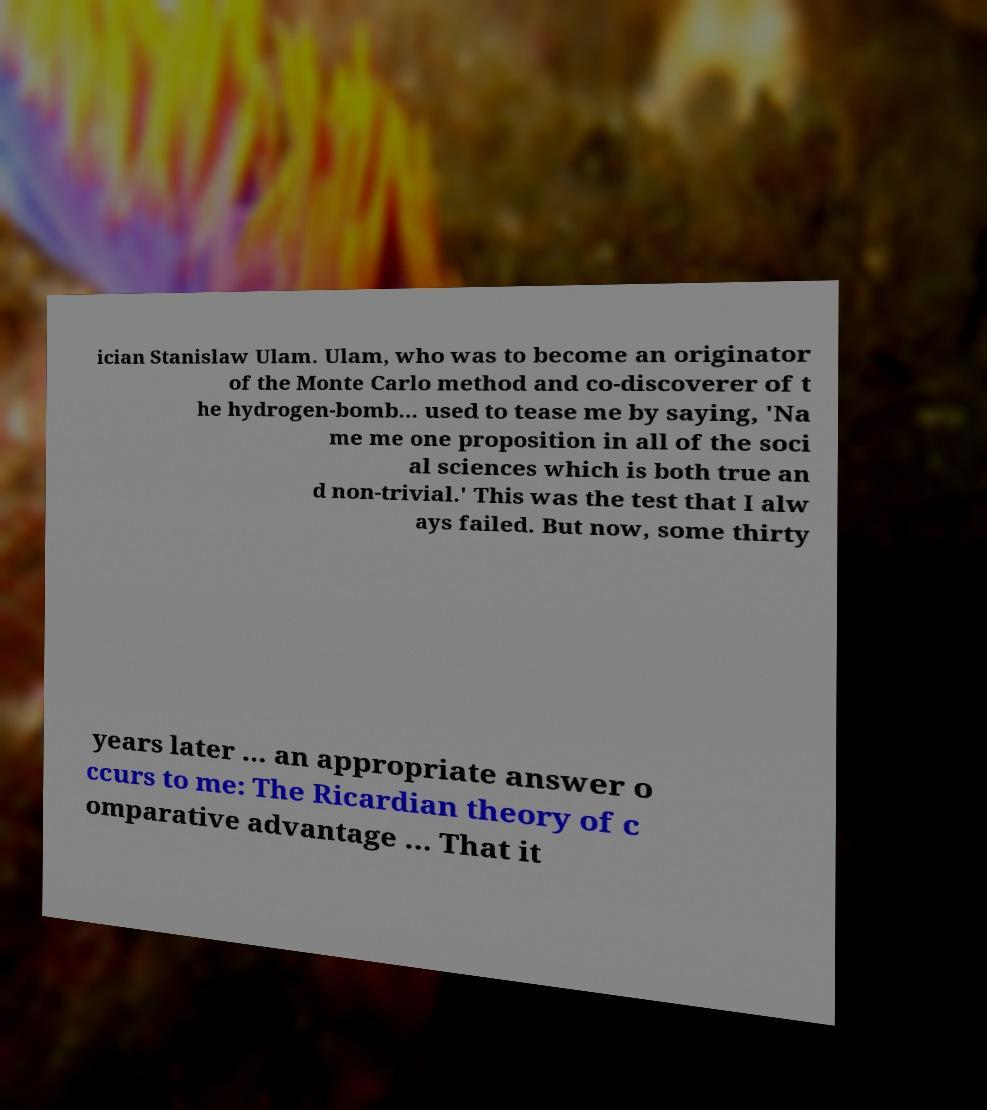Could you assist in decoding the text presented in this image and type it out clearly? ician Stanislaw Ulam. Ulam, who was to become an originator of the Monte Carlo method and co-discoverer of t he hydrogen-bomb... used to tease me by saying, 'Na me me one proposition in all of the soci al sciences which is both true an d non-trivial.' This was the test that I alw ays failed. But now, some thirty years later ... an appropriate answer o ccurs to me: The Ricardian theory of c omparative advantage ... That it 